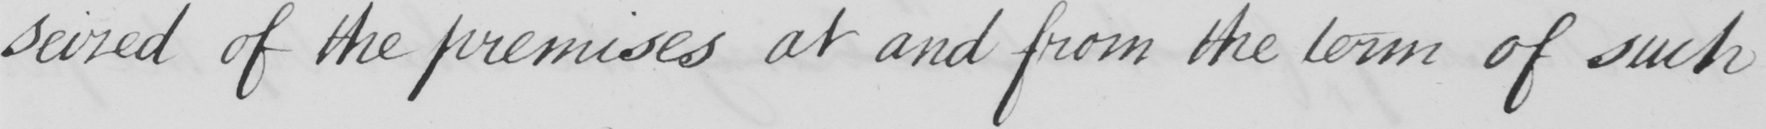Can you read and transcribe this handwriting? seized of the premises at and from the term of such 